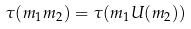Convert formula to latex. <formula><loc_0><loc_0><loc_500><loc_500>\tau ( m _ { 1 } m _ { 2 } ) = \tau ( m _ { 1 } U ( m _ { 2 } ) )</formula> 